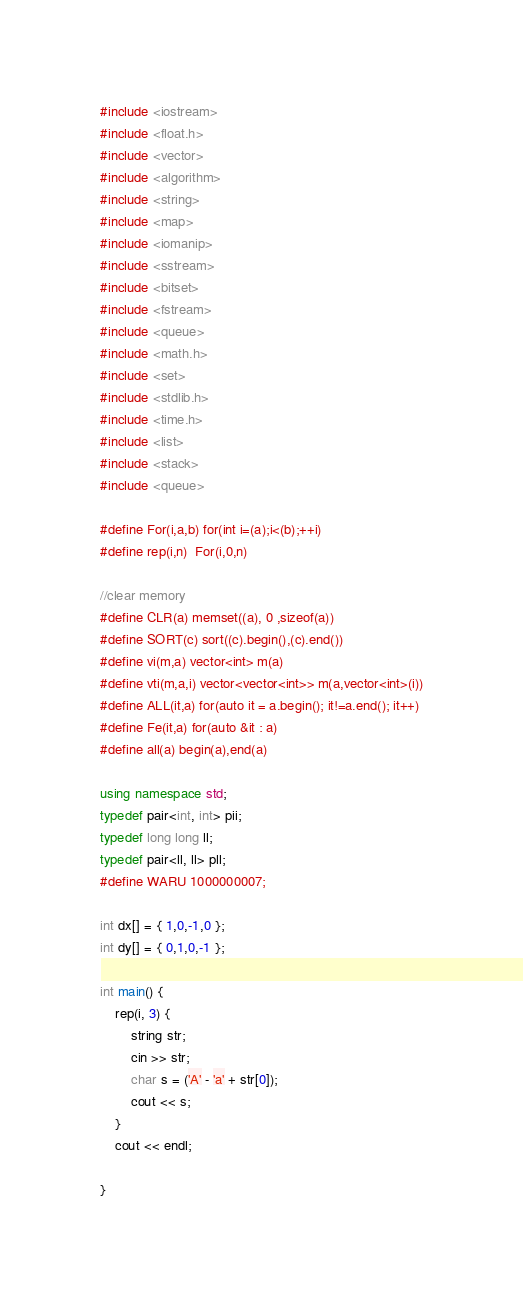<code> <loc_0><loc_0><loc_500><loc_500><_C++_>#include <iostream>
#include <float.h>
#include <vector>
#include <algorithm>
#include <string>
#include <map>
#include <iomanip>
#include <sstream>
#include <bitset>
#include <fstream>
#include <queue>
#include <math.h>
#include <set>
#include <stdlib.h>
#include <time.h>
#include <list>
#include <stack>
#include <queue>

#define For(i,a,b) for(int i=(a);i<(b);++i)
#define rep(i,n)  For(i,0,n)

//clear memory
#define CLR(a) memset((a), 0 ,sizeof(a))
#define SORT(c) sort((c).begin(),(c).end())
#define vi(m,a) vector<int> m(a)
#define vti(m,a,i) vector<vector<int>> m(a,vector<int>(i))
#define ALL(it,a) for(auto it = a.begin(); it!=a.end(); it++)
#define Fe(it,a) for(auto &it : a)
#define all(a) begin(a),end(a)

using namespace std;
typedef pair<int, int> pii;
typedef long long ll;
typedef pair<ll, ll> pll;
#define WARU 1000000007;

int dx[] = { 1,0,-1,0 };
int dy[] = { 0,1,0,-1 };

int main() {
	rep(i, 3) {
		string str;
		cin >> str;
		char s = ('A' - 'a' + str[0]);
		cout << s;
	}
	cout << endl;

}

</code> 